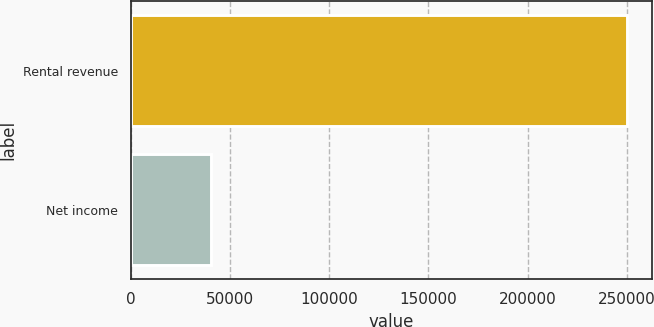Convert chart. <chart><loc_0><loc_0><loc_500><loc_500><bar_chart><fcel>Rental revenue<fcel>Net income<nl><fcel>250312<fcel>40437<nl></chart> 